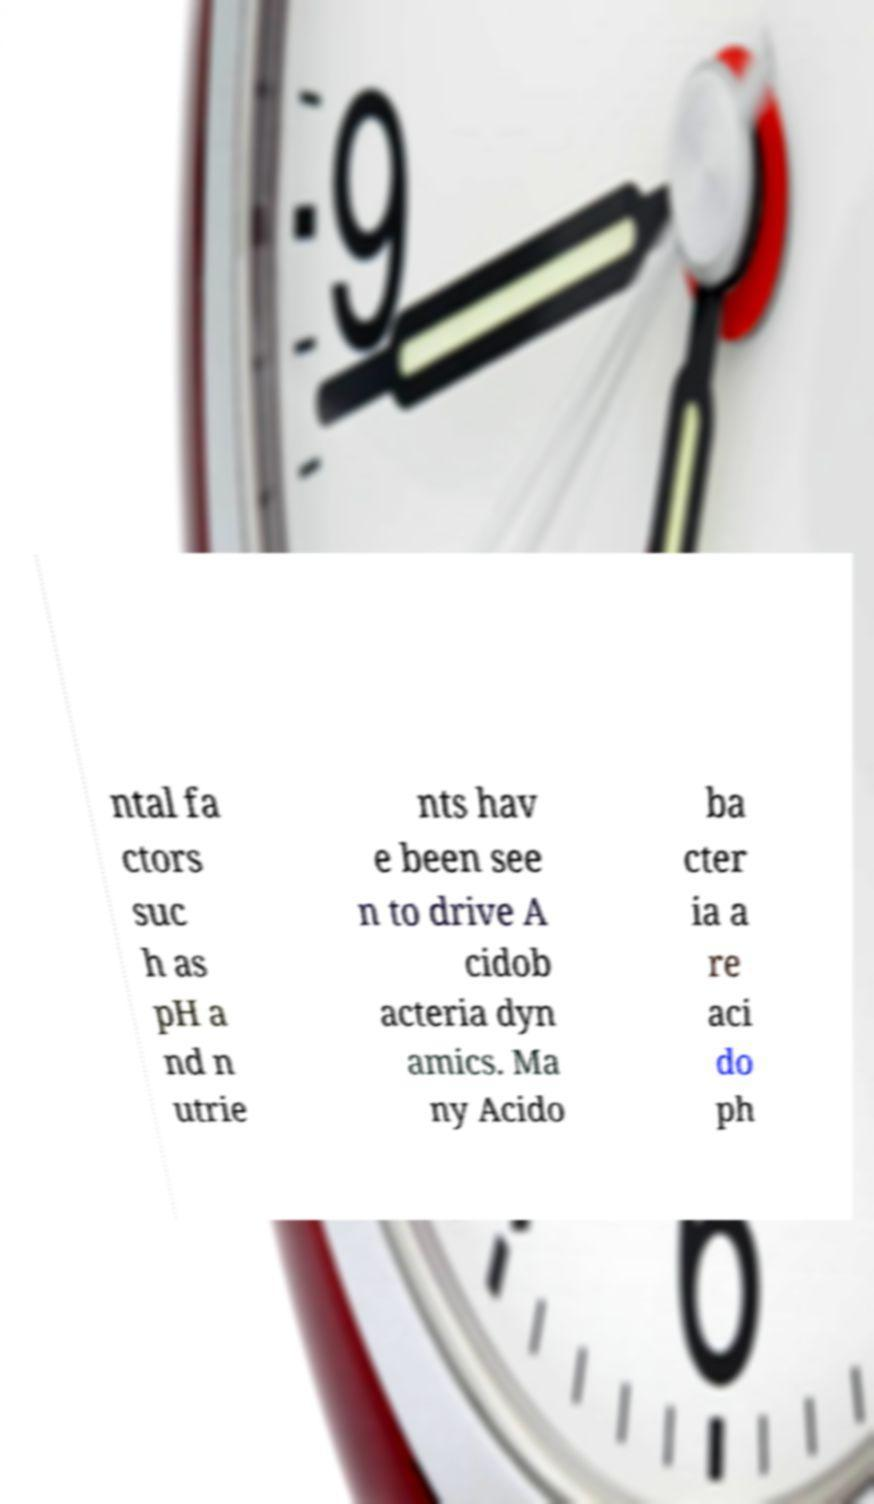Can you read and provide the text displayed in the image?This photo seems to have some interesting text. Can you extract and type it out for me? ntal fa ctors suc h as pH a nd n utrie nts hav e been see n to drive A cidob acteria dyn amics. Ma ny Acido ba cter ia a re aci do ph 